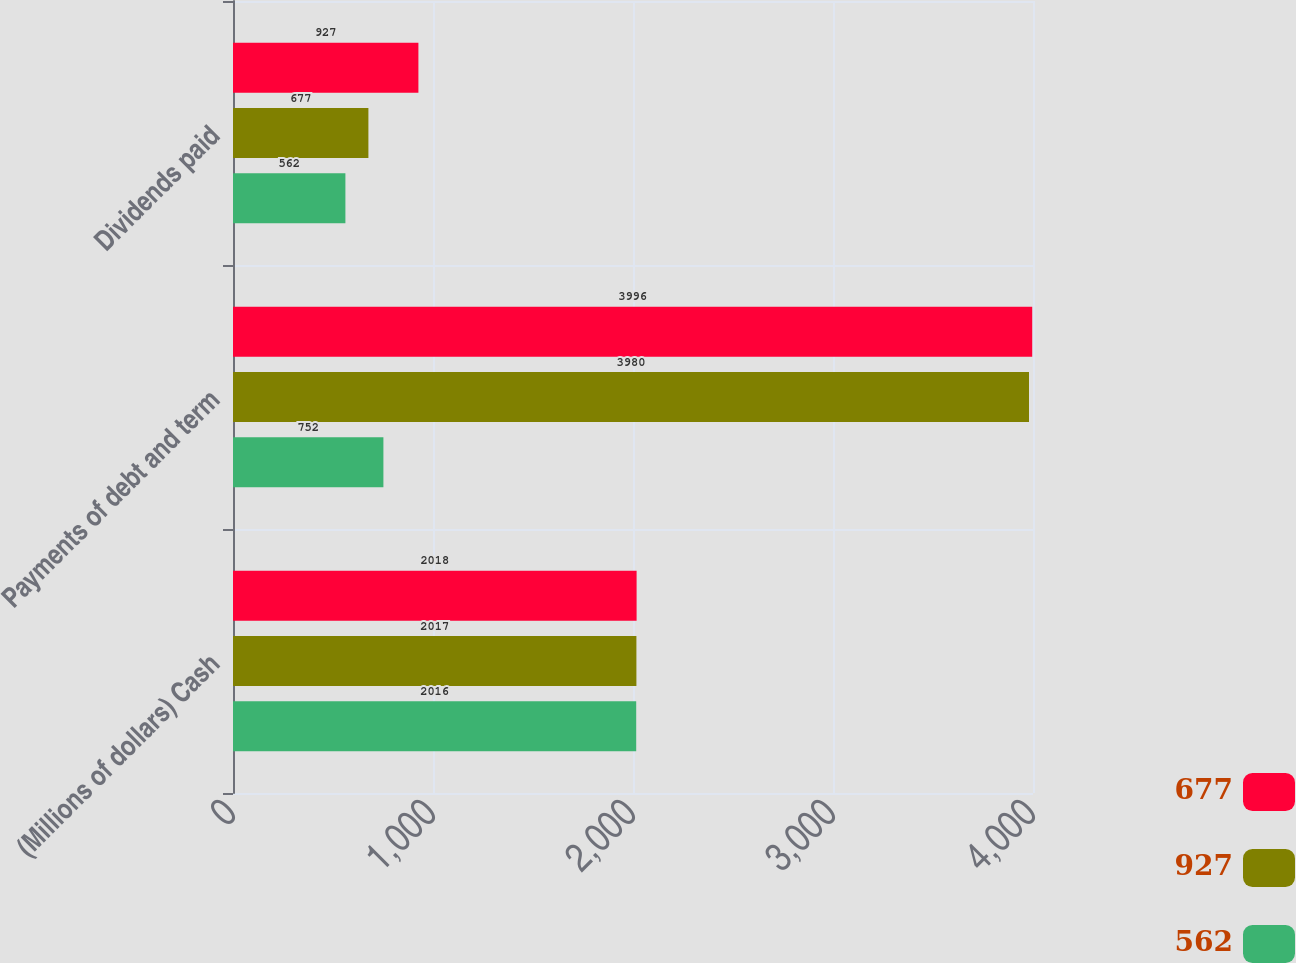Convert chart. <chart><loc_0><loc_0><loc_500><loc_500><stacked_bar_chart><ecel><fcel>(Millions of dollars) Cash<fcel>Payments of debt and term<fcel>Dividends paid<nl><fcel>677<fcel>2018<fcel>3996<fcel>927<nl><fcel>927<fcel>2017<fcel>3980<fcel>677<nl><fcel>562<fcel>2016<fcel>752<fcel>562<nl></chart> 